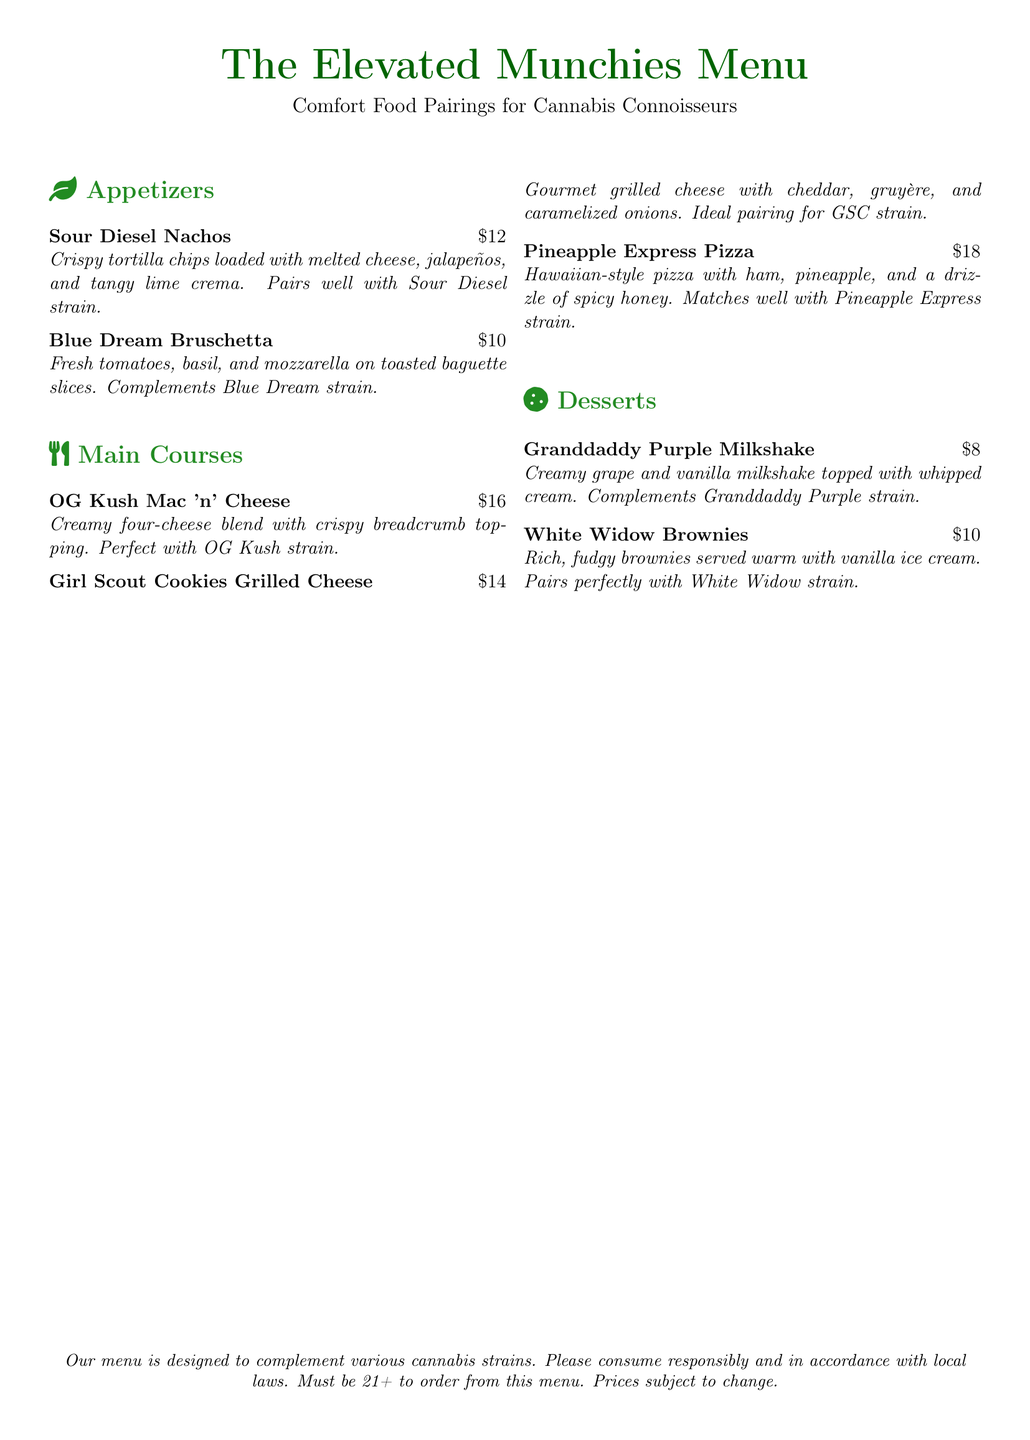What is the title of the menu? The title of the menu is displayed prominently at the top of the document.
Answer: The Elevated Munchies Menu How much do the Sour Diesel Nachos cost? The cost is listed next to the menu item in its description.
Answer: $12 Which dessert pairs with Granddaddy Purple strain? The dessert menu provides specific pairings for each item.
Answer: Granddaddy Purple Milkshake What is a unique ingredient in the Pineapple Express Pizza? The description lists specific ingredients found in this item.
Answer: Spicy honey Which type of menu item is the Girl Scout Cookies Grilled Cheese? This item is categorized under different sections of the menu, indicating its type.
Answer: Main Course 